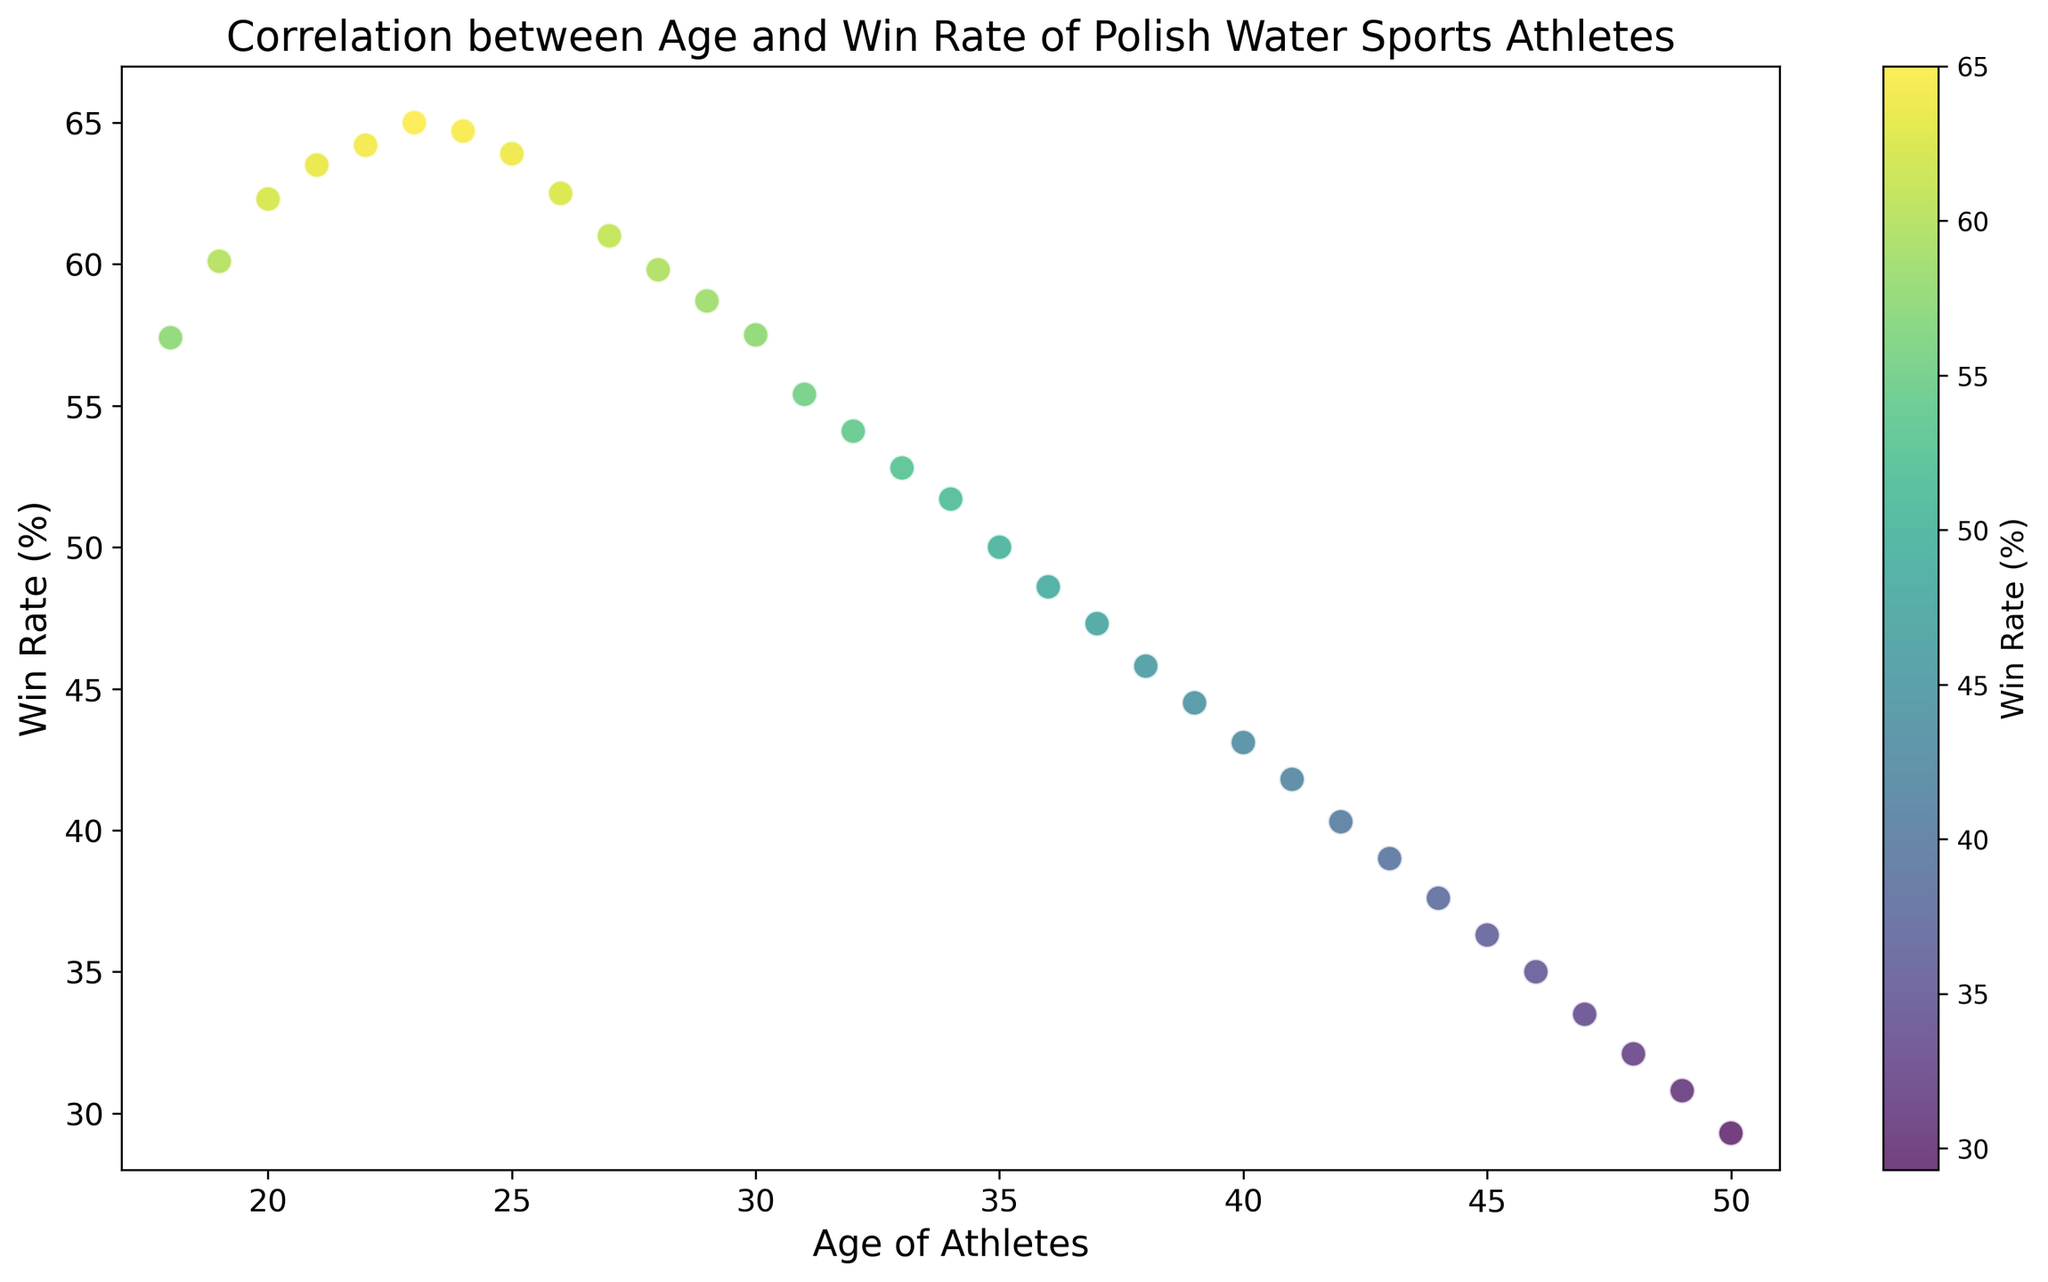What age group has the highest win rate? By looking at the scatter plot, the point at age 23 has the highest vertical position, which corresponds to the highest win rate.
Answer: 23 How does the win rate change from age 22 to age 23? By observing the scatter plot, the win rate at age 22 is around 64.2%, and at age 23, it is around 65.0%. The difference is 65.0% - 64.2% = 0.8%.
Answer: 0.8% What is the average win rate for athletes aged 20 to 25? The ages 20 through 25 have win rates of 62.3%, 63.5%, 64.2%, 65.0%, 64.7%, and 63.9%. Sum these values: 62.3 + 63.5 + 64.2 + 65.0 + 64.7 + 63.9 = 383.6. Divide by the number of ages (6) to get the average: 383.6 / 6 = 63.93%.
Answer: 63.93% At what age does the win rate start decreasing consistently? Observing the scatter plot, after age 23, the win rate shows a consistent decline.
Answer: 24 Is there a significant difference in win rates between athletes aged 30 and 40? By checking the scatter plot, the win rate at age 30 is around 57.5%, and at age 40, it is around 43.1%. The difference is 57.5% - 43.1% = 14.4%.
Answer: 14.4% Which age has a win rate closest to 50%? By examining the scatter plot, the win rate closest to 50% appears to be at age 35.
Answer: 35 Does the win rate for athletes aged 18 to 22 show an upward trend or a downward trend? Observing the scatter plot, the win rate from age 18 (57.4%) to 22 (64.2%) shows an upward trend.
Answer: Upward trend How many age groups have win rates above 60%? On the scatter plot, ages 19 through 26 have win rates above 60%; these are 19, 20, 21, 22, 23, 24, 25, and 26. So, there are 8 age groups.
Answer: 8 What is the win rate at the peak age compared to the win rate at age 50? The win rate at the peak age of 23 is around 65.0%, and at age 50, it is around 29.3%. The difference is 65.0% - 29.3% = 35.7%.
Answer: 35.7% How does the win rate change from age 35 to age 40? The win rate at age 35 is around 50.0%, and at age 40, it is around 43.1%. The difference is 50.0% - 43.1% = 6.9%.
Answer: 6.9% 